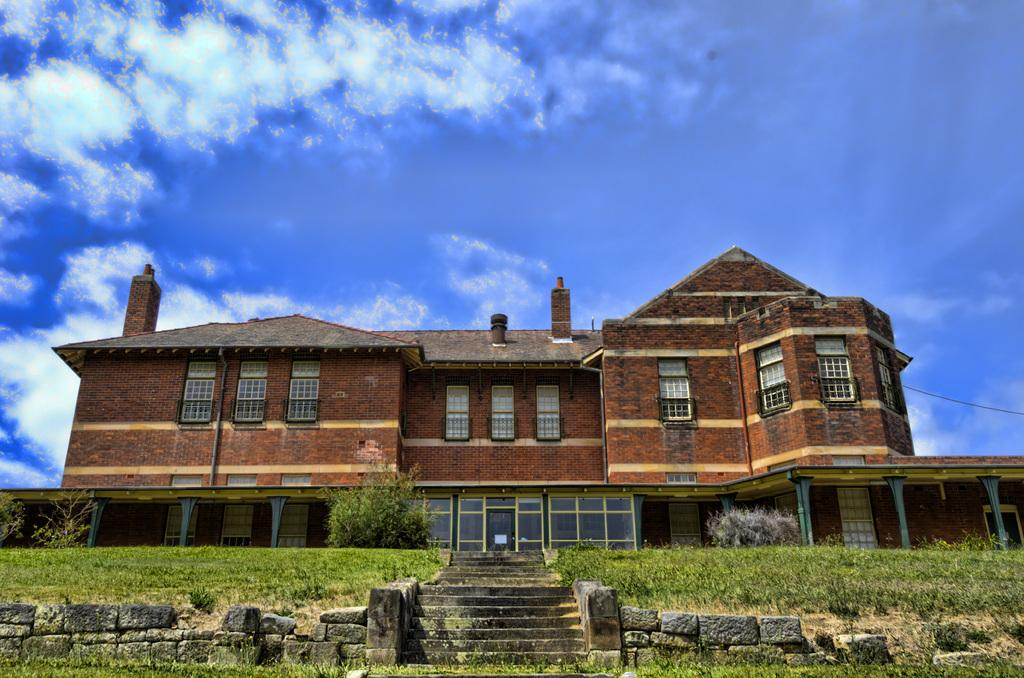What type of structure can be seen in the image? There is a stone wall and a brick building in the image. Are there any architectural features in the image? Yes, there are stairs in the image. What type of natural environment is visible in the image? There is grass and trees in the image. What is visible in the background of the image? The sky is visible in the background of the image, with clouds present. Can you see a boat navigating through the grass in the image? No, there is no boat present in the image. How many ladybugs are crawling on the stone wall in the image? There are no ladybugs visible in the image. 